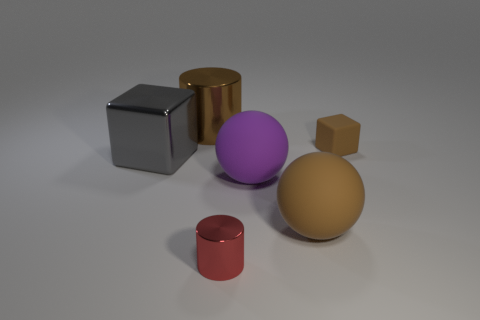Do the big metallic cylinder and the tiny rubber cube have the same color?
Give a very brief answer. Yes. Is the material of the large thing on the left side of the large cylinder the same as the cylinder that is behind the small red thing?
Provide a succinct answer. Yes. What is the color of the big cube that is the same material as the red object?
Keep it short and to the point. Gray. What number of brown cylinders have the same size as the purple thing?
Ensure brevity in your answer.  1. What number of other things are there of the same color as the large cylinder?
Your response must be concise. 2. There is a shiny object in front of the large brown matte sphere; does it have the same shape as the large brown object that is to the right of the tiny red metallic cylinder?
Your response must be concise. No. The brown matte object that is the same size as the brown cylinder is what shape?
Provide a succinct answer. Sphere. Are there an equal number of big purple matte spheres behind the large gray cube and small metal things in front of the small red cylinder?
Make the answer very short. Yes. Are there any other things that have the same shape as the gray thing?
Provide a short and direct response. Yes. Are the big brown thing behind the gray object and the tiny block made of the same material?
Offer a terse response. No. 